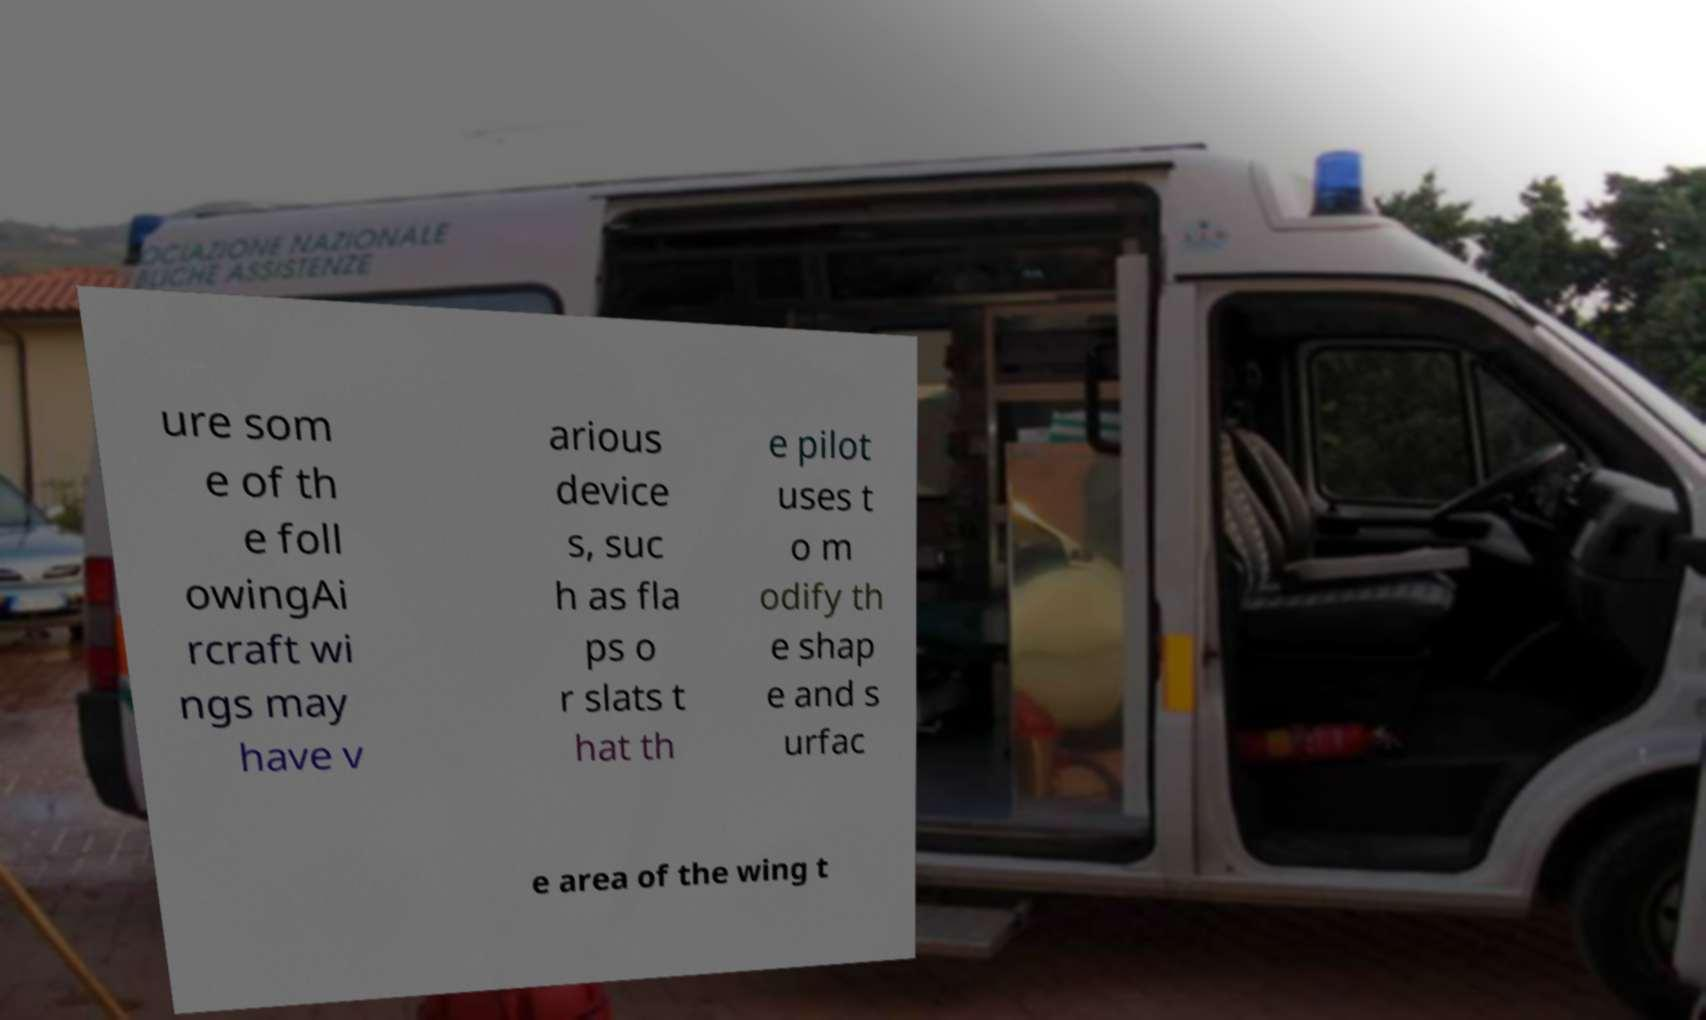There's text embedded in this image that I need extracted. Can you transcribe it verbatim? ure som e of th e foll owingAi rcraft wi ngs may have v arious device s, suc h as fla ps o r slats t hat th e pilot uses t o m odify th e shap e and s urfac e area of the wing t 